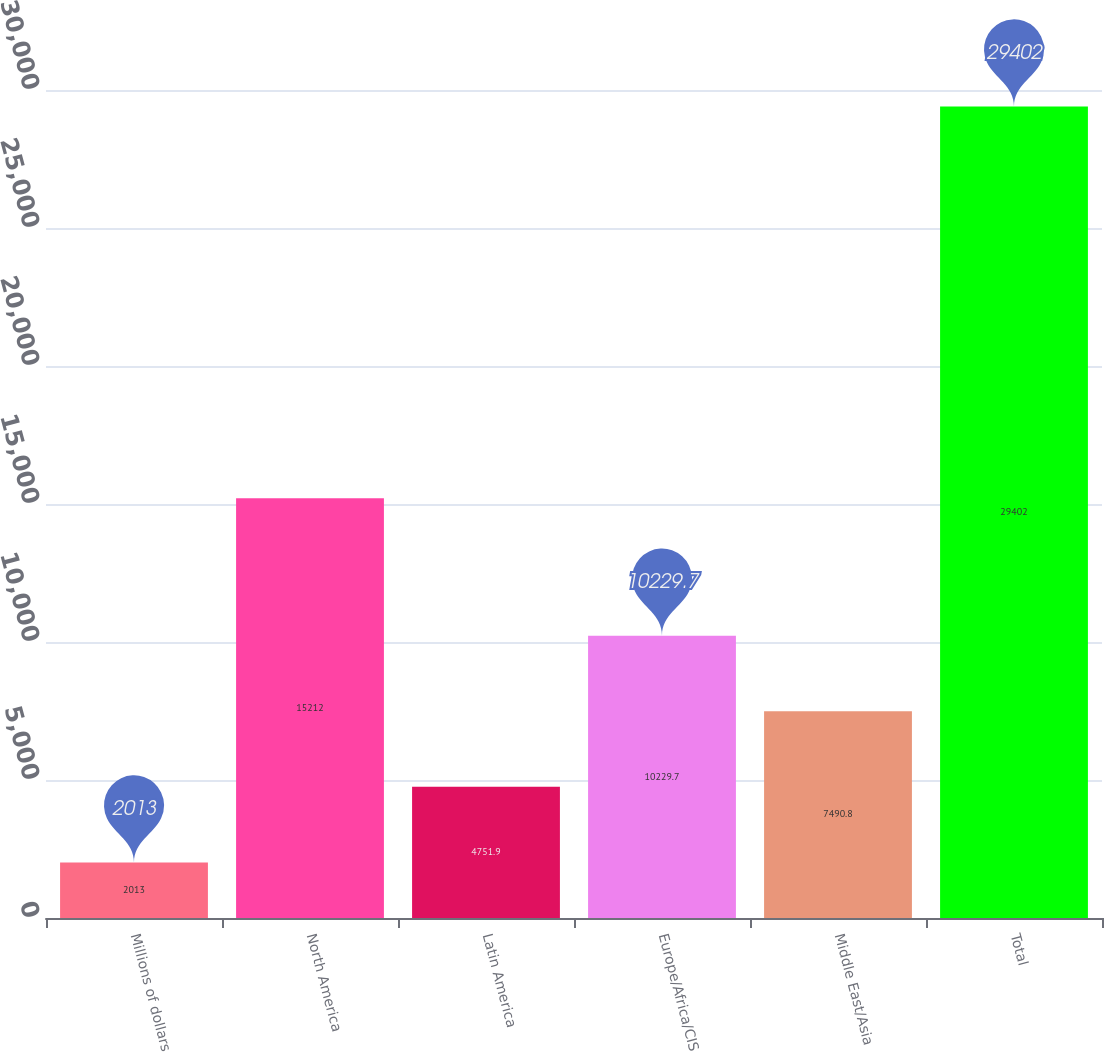Convert chart to OTSL. <chart><loc_0><loc_0><loc_500><loc_500><bar_chart><fcel>Millions of dollars<fcel>North America<fcel>Latin America<fcel>Europe/Africa/CIS<fcel>Middle East/Asia<fcel>Total<nl><fcel>2013<fcel>15212<fcel>4751.9<fcel>10229.7<fcel>7490.8<fcel>29402<nl></chart> 